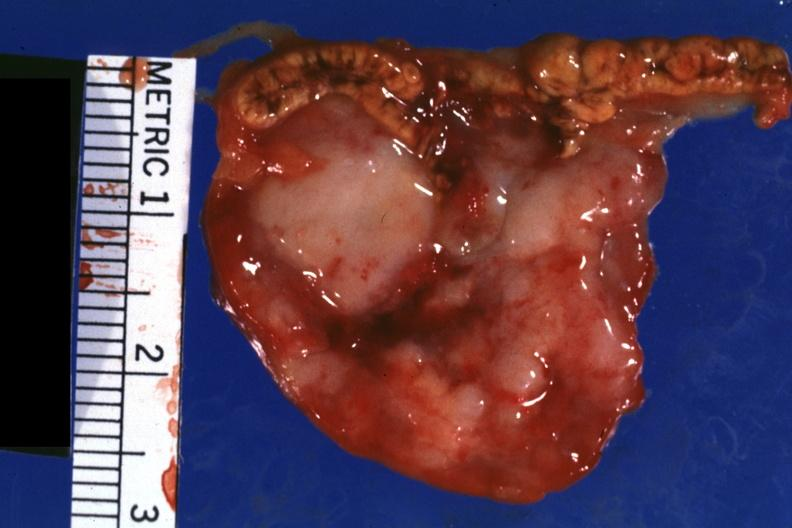what is close-up tumor well?
Answer the question using a single word or phrase. Tumor shown 